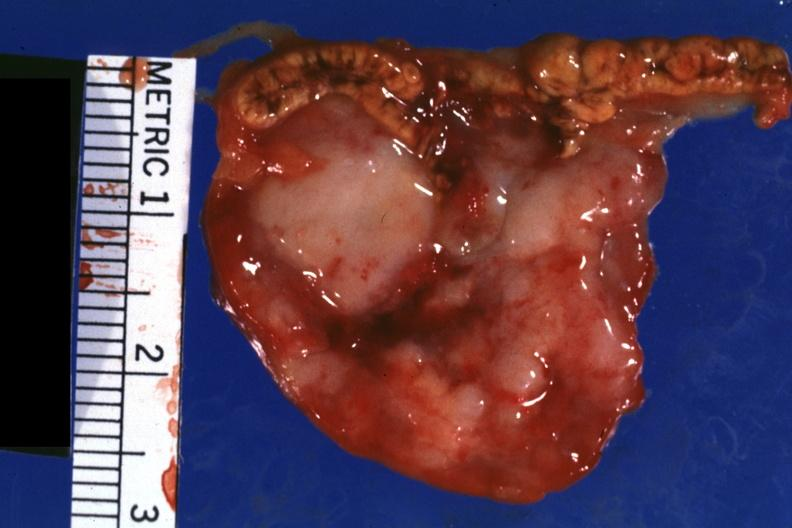what is close-up tumor well?
Answer the question using a single word or phrase. Tumor shown 